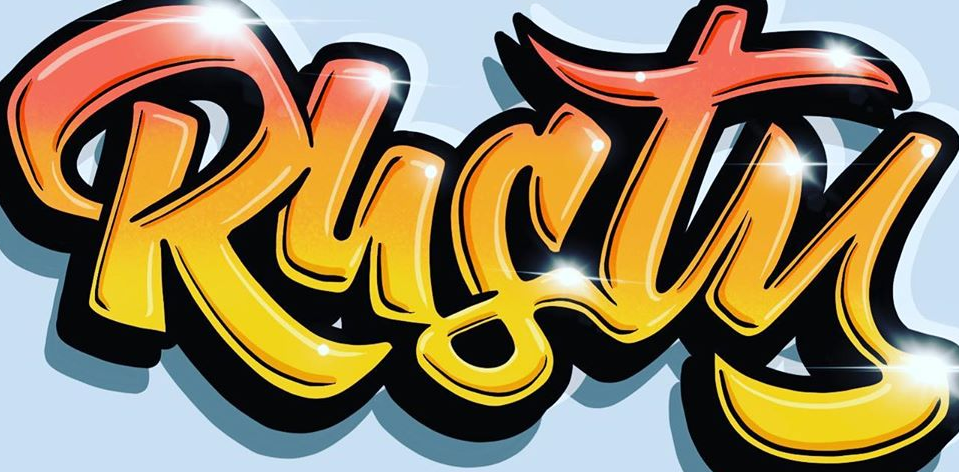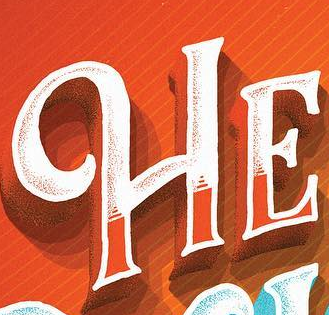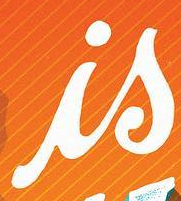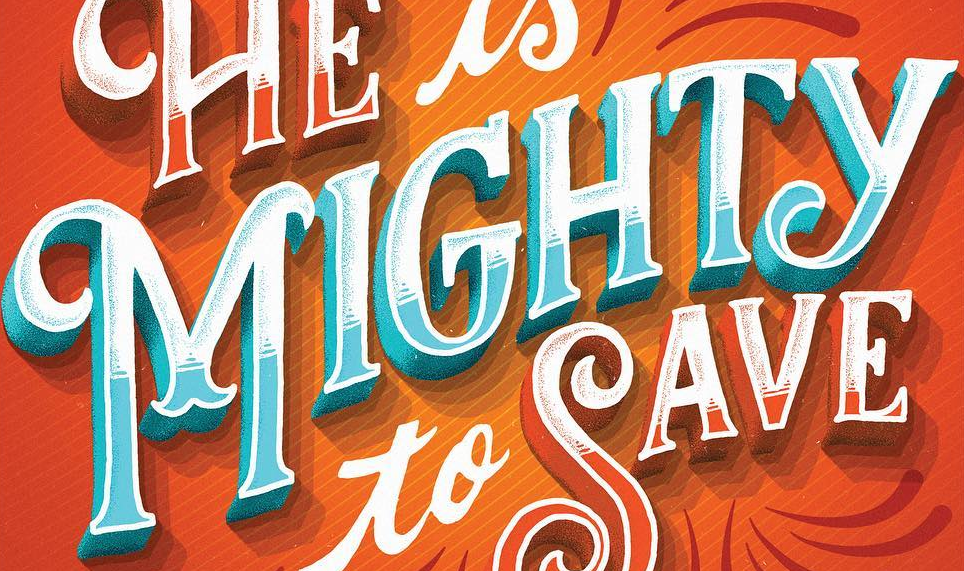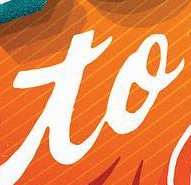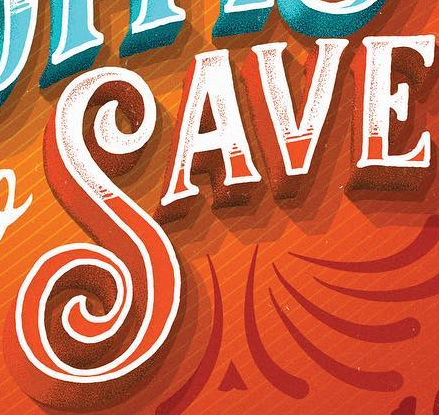What text appears in these images from left to right, separated by a semicolon? Rusty; HE; is; MIGHTY; to; SAVE 